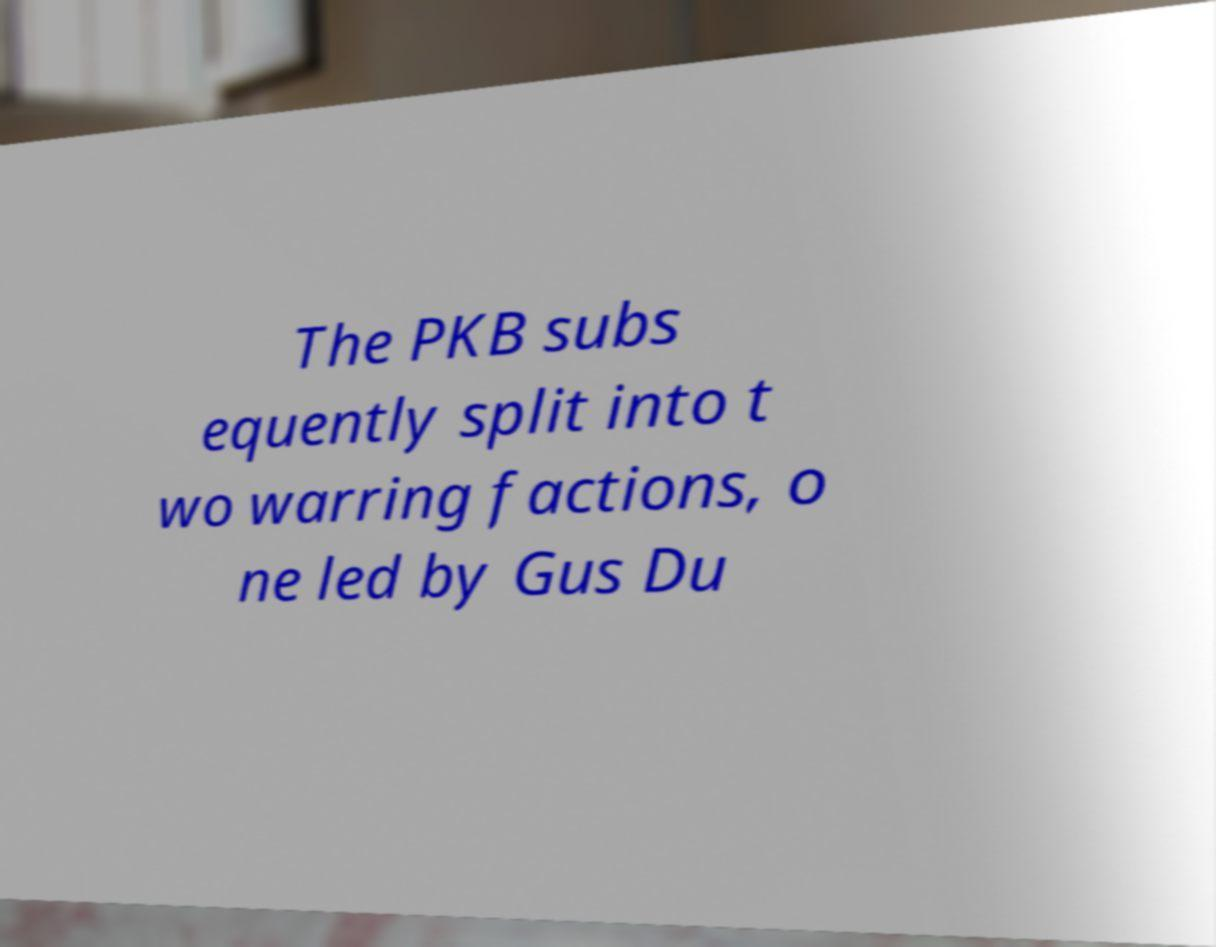I need the written content from this picture converted into text. Can you do that? The PKB subs equently split into t wo warring factions, o ne led by Gus Du 